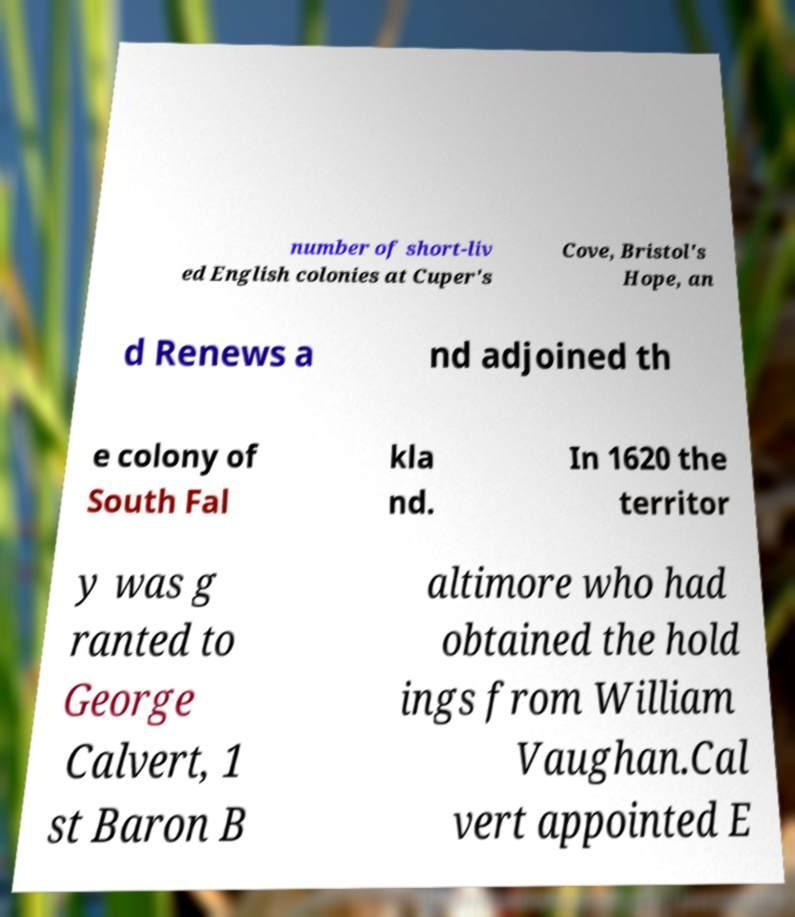What messages or text are displayed in this image? I need them in a readable, typed format. number of short-liv ed English colonies at Cuper's Cove, Bristol's Hope, an d Renews a nd adjoined th e colony of South Fal kla nd. In 1620 the territor y was g ranted to George Calvert, 1 st Baron B altimore who had obtained the hold ings from William Vaughan.Cal vert appointed E 